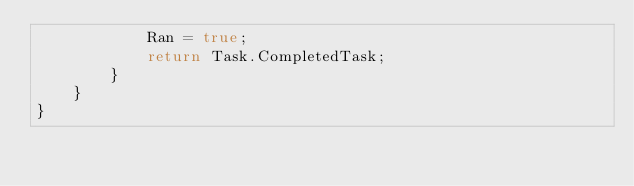Convert code to text. <code><loc_0><loc_0><loc_500><loc_500><_C#_>            Ran = true;
            return Task.CompletedTask;
        }
    }
}</code> 